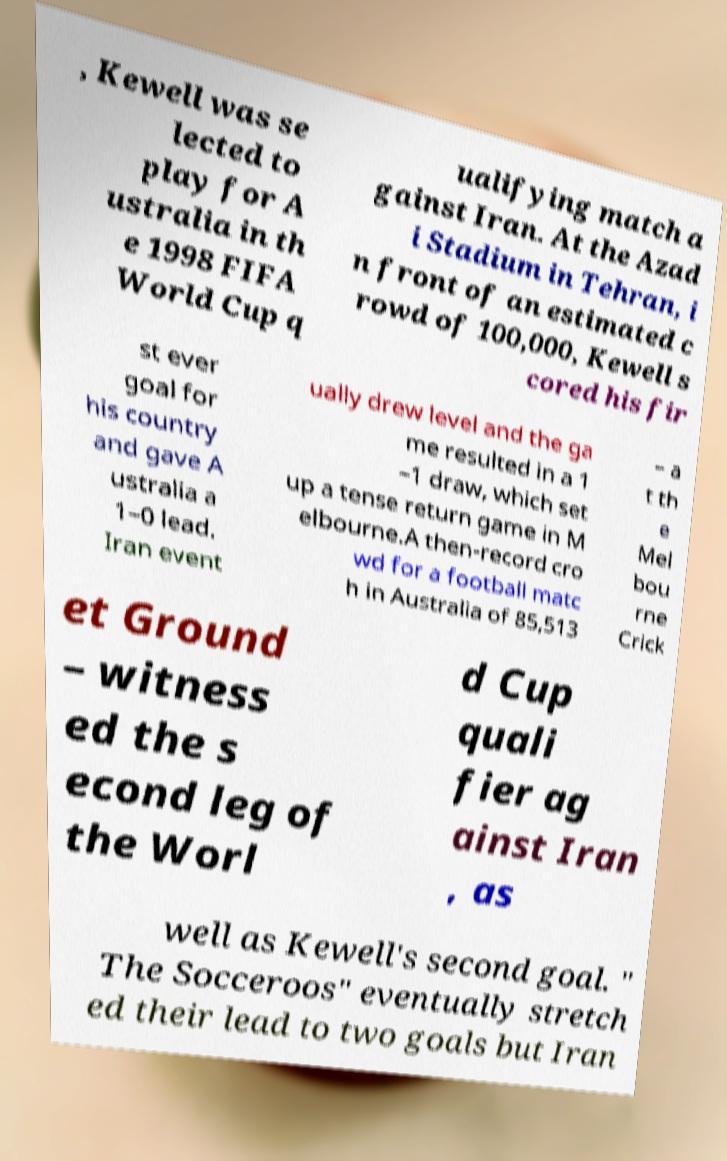Can you read and provide the text displayed in the image?This photo seems to have some interesting text. Can you extract and type it out for me? , Kewell was se lected to play for A ustralia in th e 1998 FIFA World Cup q ualifying match a gainst Iran. At the Azad i Stadium in Tehran, i n front of an estimated c rowd of 100,000, Kewell s cored his fir st ever goal for his country and gave A ustralia a 1–0 lead. Iran event ually drew level and the ga me resulted in a 1 –1 draw, which set up a tense return game in M elbourne.A then-record cro wd for a football matc h in Australia of 85,513 – a t th e Mel bou rne Crick et Ground – witness ed the s econd leg of the Worl d Cup quali fier ag ainst Iran , as well as Kewell's second goal. " The Socceroos" eventually stretch ed their lead to two goals but Iran 